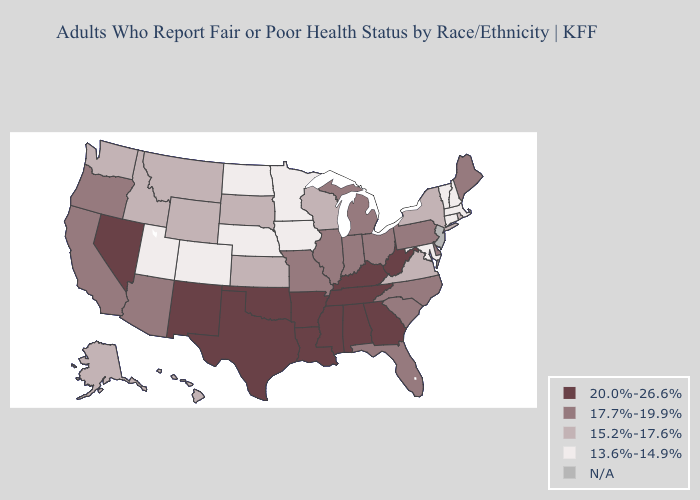Name the states that have a value in the range 17.7%-19.9%?
Concise answer only. Arizona, California, Delaware, Florida, Illinois, Indiana, Maine, Michigan, Missouri, North Carolina, Ohio, Oregon, Pennsylvania, South Carolina. What is the value of Arkansas?
Be succinct. 20.0%-26.6%. What is the lowest value in states that border Montana?
Give a very brief answer. 13.6%-14.9%. Name the states that have a value in the range 13.6%-14.9%?
Quick response, please. Colorado, Connecticut, Iowa, Maryland, Massachusetts, Minnesota, Nebraska, New Hampshire, North Dakota, Utah, Vermont. Does Colorado have the lowest value in the West?
Write a very short answer. Yes. Among the states that border Idaho , does Nevada have the highest value?
Give a very brief answer. Yes. What is the value of Rhode Island?
Answer briefly. 15.2%-17.6%. Does West Virginia have the lowest value in the South?
Short answer required. No. Name the states that have a value in the range 17.7%-19.9%?
Be succinct. Arizona, California, Delaware, Florida, Illinois, Indiana, Maine, Michigan, Missouri, North Carolina, Ohio, Oregon, Pennsylvania, South Carolina. What is the value of California?
Keep it brief. 17.7%-19.9%. What is the value of Iowa?
Keep it brief. 13.6%-14.9%. What is the value of Virginia?
Answer briefly. 15.2%-17.6%. Name the states that have a value in the range 17.7%-19.9%?
Be succinct. Arizona, California, Delaware, Florida, Illinois, Indiana, Maine, Michigan, Missouri, North Carolina, Ohio, Oregon, Pennsylvania, South Carolina. 